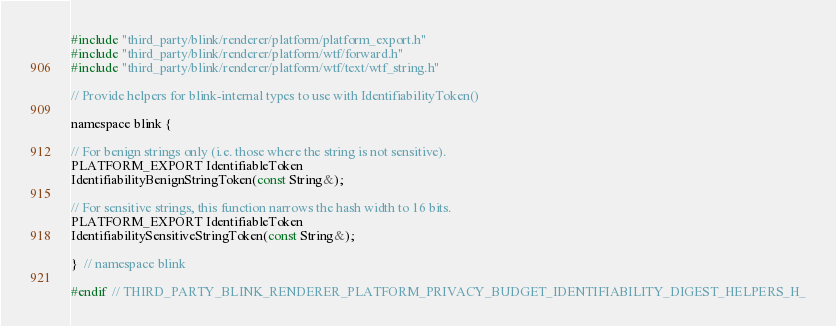<code> <loc_0><loc_0><loc_500><loc_500><_C_>#include "third_party/blink/renderer/platform/platform_export.h"
#include "third_party/blink/renderer/platform/wtf/forward.h"
#include "third_party/blink/renderer/platform/wtf/text/wtf_string.h"

// Provide helpers for blink-internal types to use with IdentifiabilityToken()

namespace blink {

// For benign strings only (i.e. those where the string is not sensitive).
PLATFORM_EXPORT IdentifiableToken
IdentifiabilityBenignStringToken(const String&);

// For sensitive strings, this function narrows the hash width to 16 bits.
PLATFORM_EXPORT IdentifiableToken
IdentifiabilitySensitiveStringToken(const String&);

}  // namespace blink

#endif  // THIRD_PARTY_BLINK_RENDERER_PLATFORM_PRIVACY_BUDGET_IDENTIFIABILITY_DIGEST_HELPERS_H_
</code> 